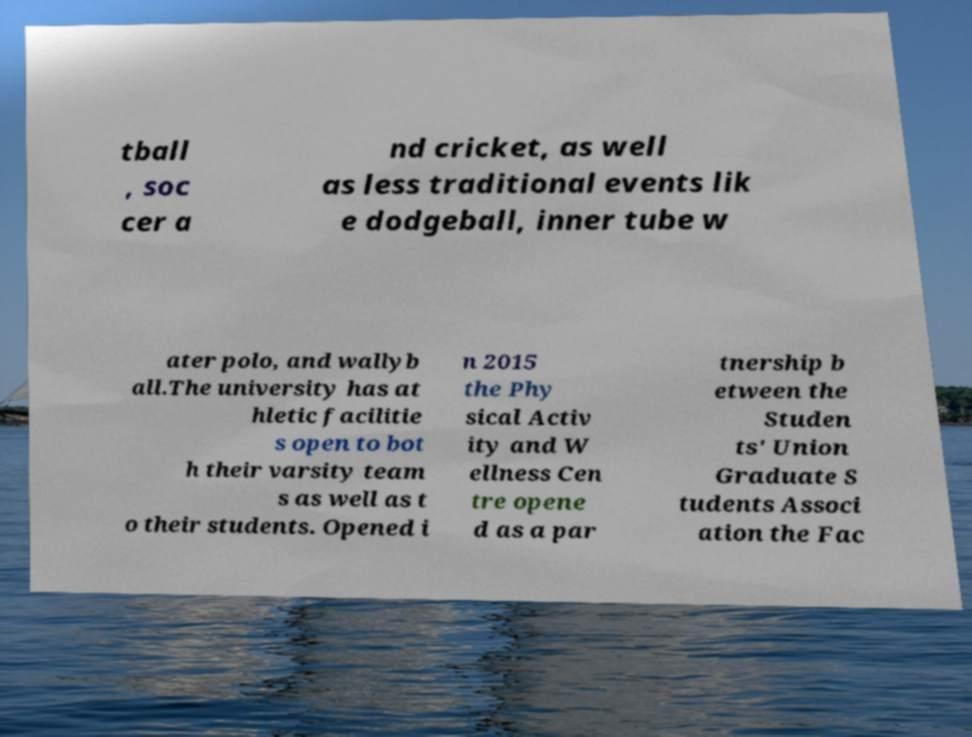Please read and relay the text visible in this image. What does it say? tball , soc cer a nd cricket, as well as less traditional events lik e dodgeball, inner tube w ater polo, and wallyb all.The university has at hletic facilitie s open to bot h their varsity team s as well as t o their students. Opened i n 2015 the Phy sical Activ ity and W ellness Cen tre opene d as a par tnership b etween the Studen ts' Union Graduate S tudents Associ ation the Fac 